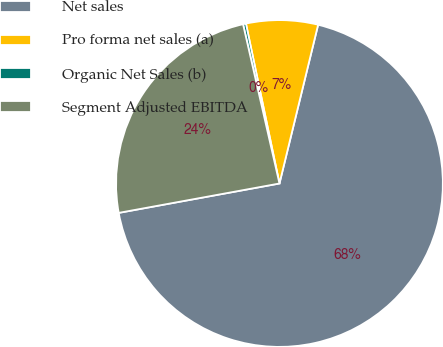Convert chart to OTSL. <chart><loc_0><loc_0><loc_500><loc_500><pie_chart><fcel>Net sales<fcel>Pro forma net sales (a)<fcel>Organic Net Sales (b)<fcel>Segment Adjusted EBITDA<nl><fcel>68.32%<fcel>7.09%<fcel>0.29%<fcel>24.3%<nl></chart> 